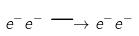Convert formula to latex. <formula><loc_0><loc_0><loc_500><loc_500>e ^ { - } e ^ { - } \longrightarrow e ^ { - } e ^ { - }</formula> 